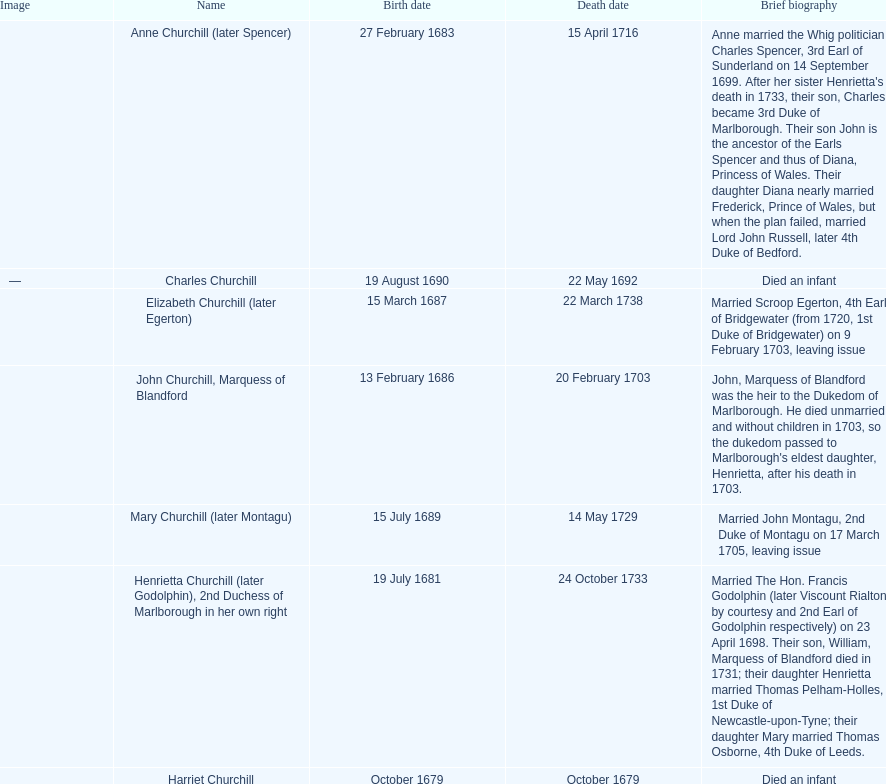What is the total number of children listed? 7. 